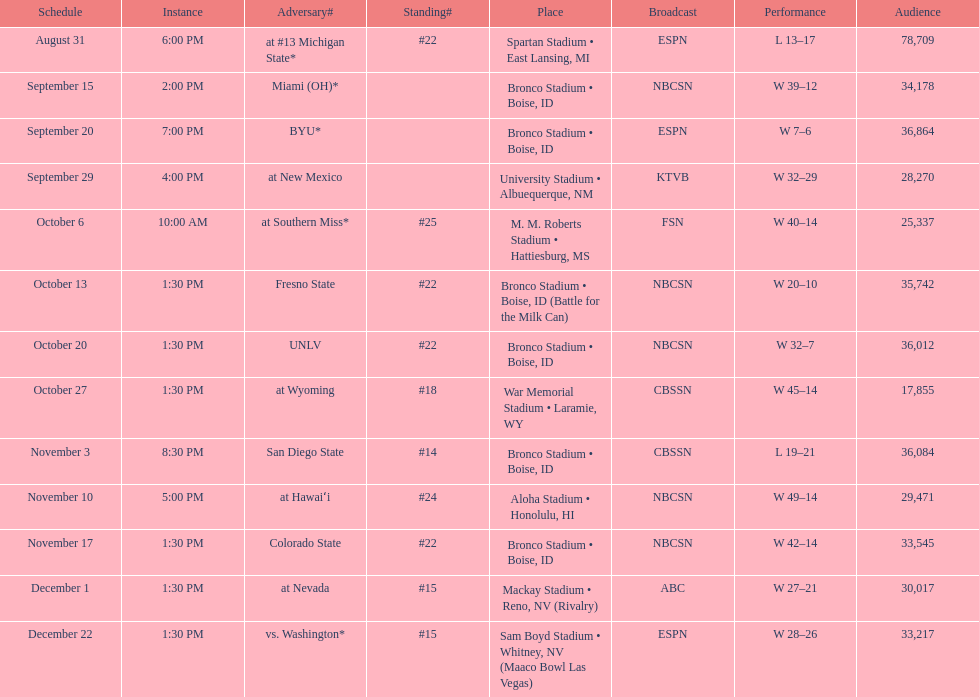What are all of the rankings? #22, , , , #25, #22, #22, #18, #14, #24, #22, #15, #15. Which of them was the best position? #14. 